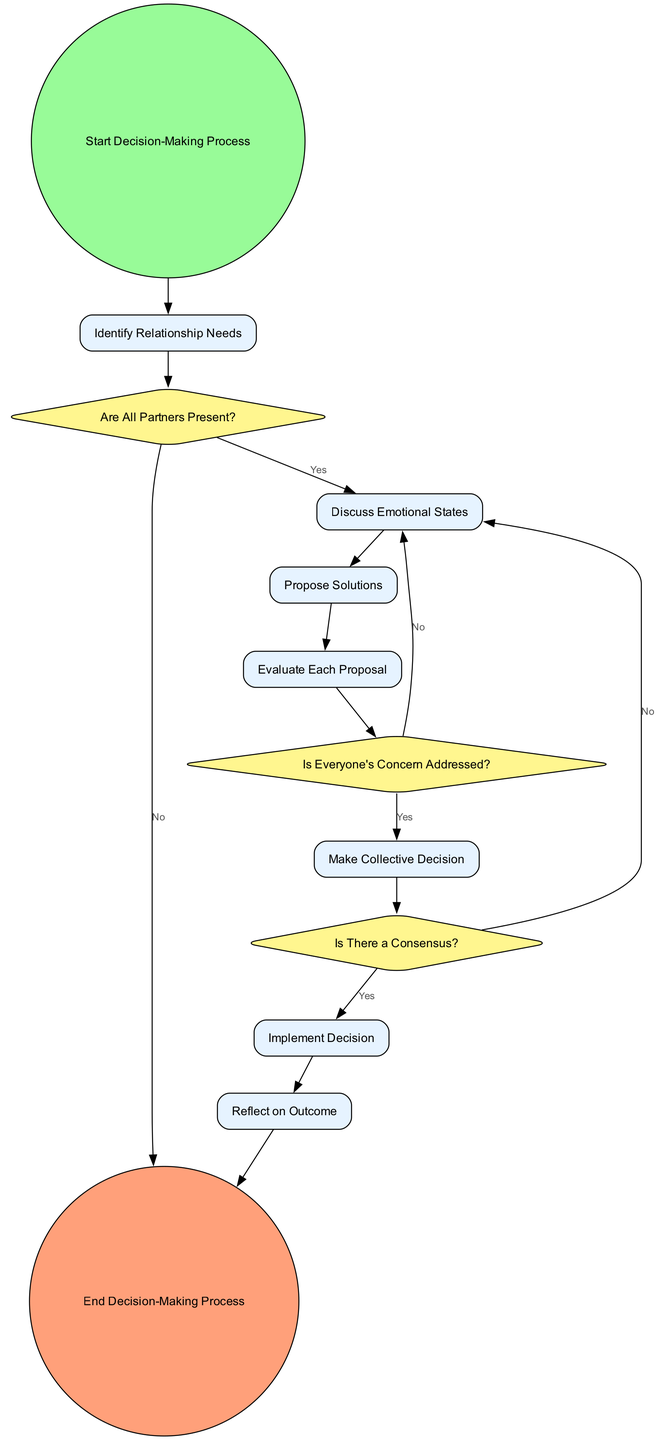What is the starting point of the decision-making process? The diagram indicates that the decision-making process begins at the node labeled "Start Decision-Making Process". This is the entry point from which the subsequent activities flow.
Answer: Start Decision-Making Process How many partners are involved in the decision-making process? The diagram specifies three actors: Partner A, Partner B, and Partner C. They are the primary participants in the decision-making flow.
Answer: Three What happens if not all partners are present? According to the diagram, if not all partners are present, the flow directs to the "End Decision-Making Process" node. This indicates that the decision-making cannot proceed without everyone's presence.
Answer: End Decision-Making Process What is the condition checked after evaluating each proposal? The diagram shows that after evaluating each proposal, the next decision checked is "Is Everyone's Concern Addressed?". This is a prerequisite to making a collective decision.
Answer: Is Everyone's Concern Addressed? If there is no consensus, where do the partners go next? The diagram indicates that if there is no consensus, the flow goes back to "Discuss Emotional States". This loop allows the partners to reassess their feelings and concerns before attempting to reach a consensus again.
Answer: Discuss Emotional States How many decision points are included in the workflow? The diagram presents three decision points: "Are All Partners Present?", "Is Everyone's Concern Addressed?", and "Is There a Consensus?". These points are critical for guiding the decision-making process.
Answer: Three What is the final activity after implementing a decision? The last activity that follows the implementation of the decision is "Reflect on Outcome". This step is crucial for reviewing the effectiveness of the decision made in the relationship context.
Answer: Reflect on Outcome What action occurs immediately after discussing emotional states? The activity that follows directly after "Discuss Emotional States" is "Propose Solutions". This shows a clear flow from emotional discussion to solution generation.
Answer: Propose Solutions What shape does the start node have in the diagram? The start node is represented as a circle. This is a common indicator in activity diagrams to signify the starting point of any process.
Answer: Circle Which activity comes before making a collective decision? Before making a collective decision, the activity "Evaluate Each Proposal" must take place. This is a necessary step to ensure all proposals are considered before arriving at a consensus.
Answer: Evaluate Each Proposal 